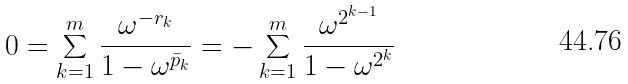Convert formula to latex. <formula><loc_0><loc_0><loc_500><loc_500>0 = \sum _ { k = 1 } ^ { m } \frac { \omega ^ { - r _ { k } } } { 1 - \omega ^ { \bar { p } _ { k } } } = - \sum _ { k = 1 } ^ { m } \frac { \omega ^ { 2 ^ { k - 1 } } } { 1 - \omega ^ { 2 ^ { k } } }</formula> 